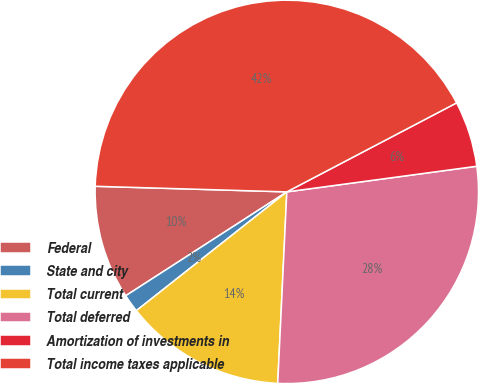<chart> <loc_0><loc_0><loc_500><loc_500><pie_chart><fcel>Federal<fcel>State and city<fcel>Total current<fcel>Total deferred<fcel>Amortization of investments in<fcel>Total income taxes applicable<nl><fcel>9.58%<fcel>1.52%<fcel>13.61%<fcel>27.89%<fcel>5.55%<fcel>41.85%<nl></chart> 